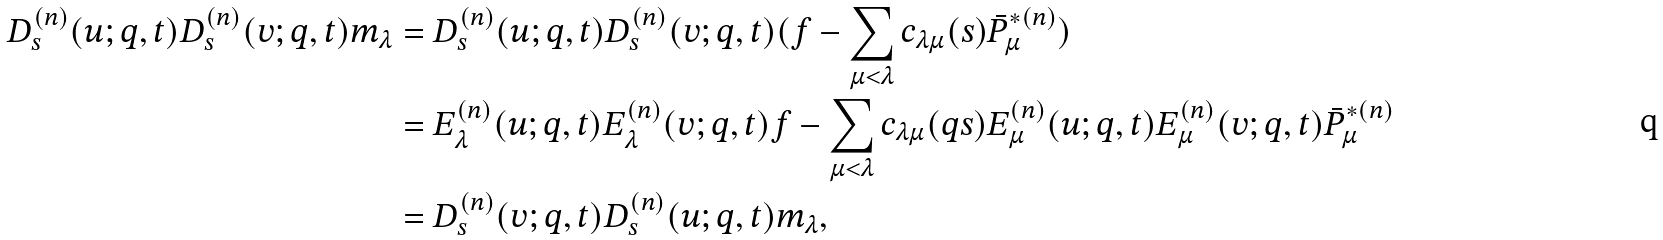Convert formula to latex. <formula><loc_0><loc_0><loc_500><loc_500>D ^ { ( n ) } _ { s } ( u ; q , t ) D ^ { ( n ) } _ { s } ( v ; q , t ) m _ { \lambda } & = D ^ { ( n ) } _ { s } ( u ; q , t ) D ^ { ( n ) } _ { s } ( v ; q , t ) ( f - \sum _ { \mu < \lambda } c _ { \lambda \mu } ( s ) \bar { P } ^ { * ( n ) } _ { \mu } ) \\ & = E ^ { ( n ) } _ { \lambda } ( u ; q , t ) E ^ { ( n ) } _ { \lambda } ( v ; q , t ) f - \sum _ { \mu < \lambda } c _ { \lambda \mu } ( q s ) E ^ { ( n ) } _ { \mu } ( u ; q , t ) E ^ { ( n ) } _ { \mu } ( v ; q , t ) \bar { P } ^ { * ( n ) } _ { \mu } \\ & = D ^ { ( n ) } _ { s } ( v ; q , t ) D ^ { ( n ) } _ { s } ( u ; q , t ) m _ { \lambda } ,</formula> 